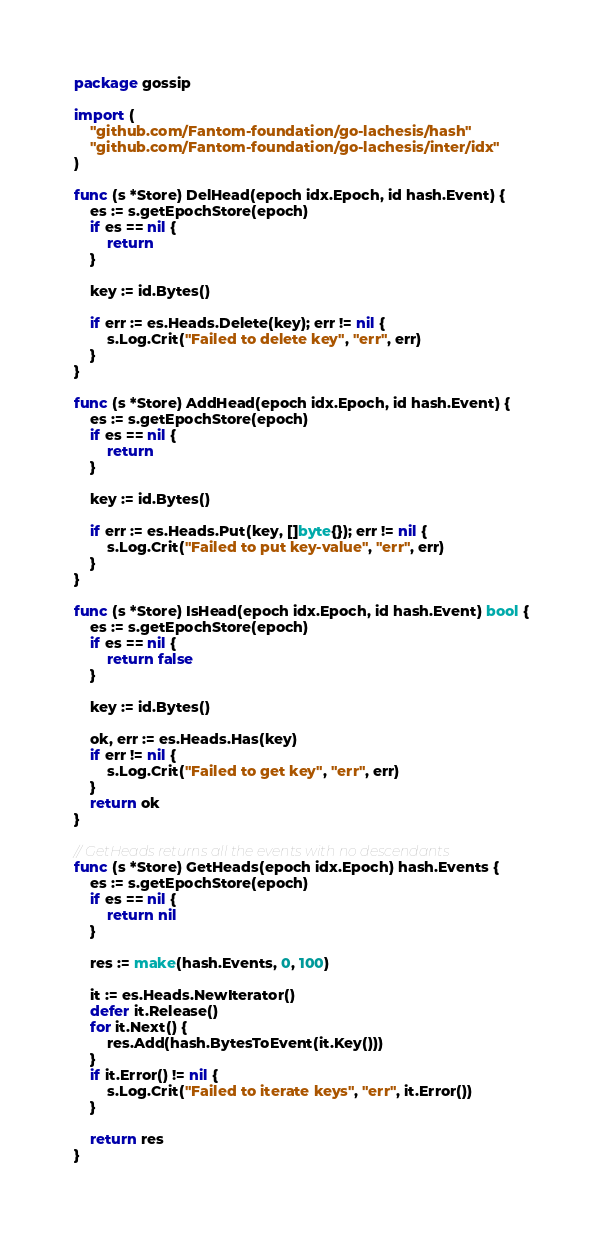<code> <loc_0><loc_0><loc_500><loc_500><_Go_>package gossip

import (
	"github.com/Fantom-foundation/go-lachesis/hash"
	"github.com/Fantom-foundation/go-lachesis/inter/idx"
)

func (s *Store) DelHead(epoch idx.Epoch, id hash.Event) {
	es := s.getEpochStore(epoch)
	if es == nil {
		return
	}

	key := id.Bytes()

	if err := es.Heads.Delete(key); err != nil {
		s.Log.Crit("Failed to delete key", "err", err)
	}
}

func (s *Store) AddHead(epoch idx.Epoch, id hash.Event) {
	es := s.getEpochStore(epoch)
	if es == nil {
		return
	}

	key := id.Bytes()

	if err := es.Heads.Put(key, []byte{}); err != nil {
		s.Log.Crit("Failed to put key-value", "err", err)
	}
}

func (s *Store) IsHead(epoch idx.Epoch, id hash.Event) bool {
	es := s.getEpochStore(epoch)
	if es == nil {
		return false
	}

	key := id.Bytes()

	ok, err := es.Heads.Has(key)
	if err != nil {
		s.Log.Crit("Failed to get key", "err", err)
	}
	return ok
}

// GetHeads returns all the events with no descendants
func (s *Store) GetHeads(epoch idx.Epoch) hash.Events {
	es := s.getEpochStore(epoch)
	if es == nil {
		return nil
	}

	res := make(hash.Events, 0, 100)

	it := es.Heads.NewIterator()
	defer it.Release()
	for it.Next() {
		res.Add(hash.BytesToEvent(it.Key()))
	}
	if it.Error() != nil {
		s.Log.Crit("Failed to iterate keys", "err", it.Error())
	}

	return res
}
</code> 